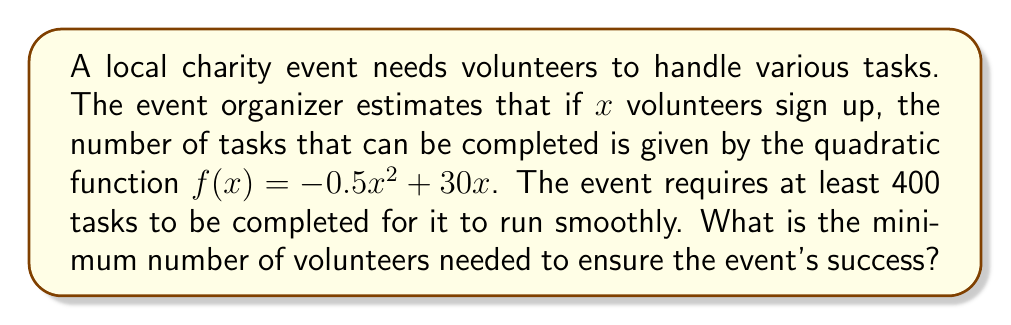Teach me how to tackle this problem. Let's approach this step-by-step:

1) We need to find $x$ such that $f(x) \geq 400$, where $f(x) = -0.5x^2 + 30x$.

2) This gives us the quadratic inequality:
   $-0.5x^2 + 30x \geq 400$

3) Rearranging the inequality:
   $-0.5x^2 + 30x - 400 \geq 0$

4) Multiplying everything by -2 (which flips the inequality sign):
   $x^2 - 60x + 800 \leq 0$

5) This is a quadratic inequality. To solve it, we first find the roots of the quadratic equation $x^2 - 60x + 800 = 0$.

6) Using the quadratic formula, $x = \frac{-b \pm \sqrt{b^2 - 4ac}}{2a}$, where $a=1$, $b=-60$, and $c=800$:

   $x = \frac{60 \pm \sqrt{3600 - 3200}}{2} = \frac{60 \pm \sqrt{400}}{2} = \frac{60 \pm 20}{2}$

7) This gives us two roots: $x_1 = 40$ and $x_2 = 20$

8) For the inequality $x^2 - 60x + 800 \leq 0$ to be true, $x$ must be between these two roots.

9) Since we're looking for the minimum number of volunteers, we need the smaller of these two values that's still an integer.

Therefore, the minimum number of volunteers needed is 20.
Answer: 20 volunteers 